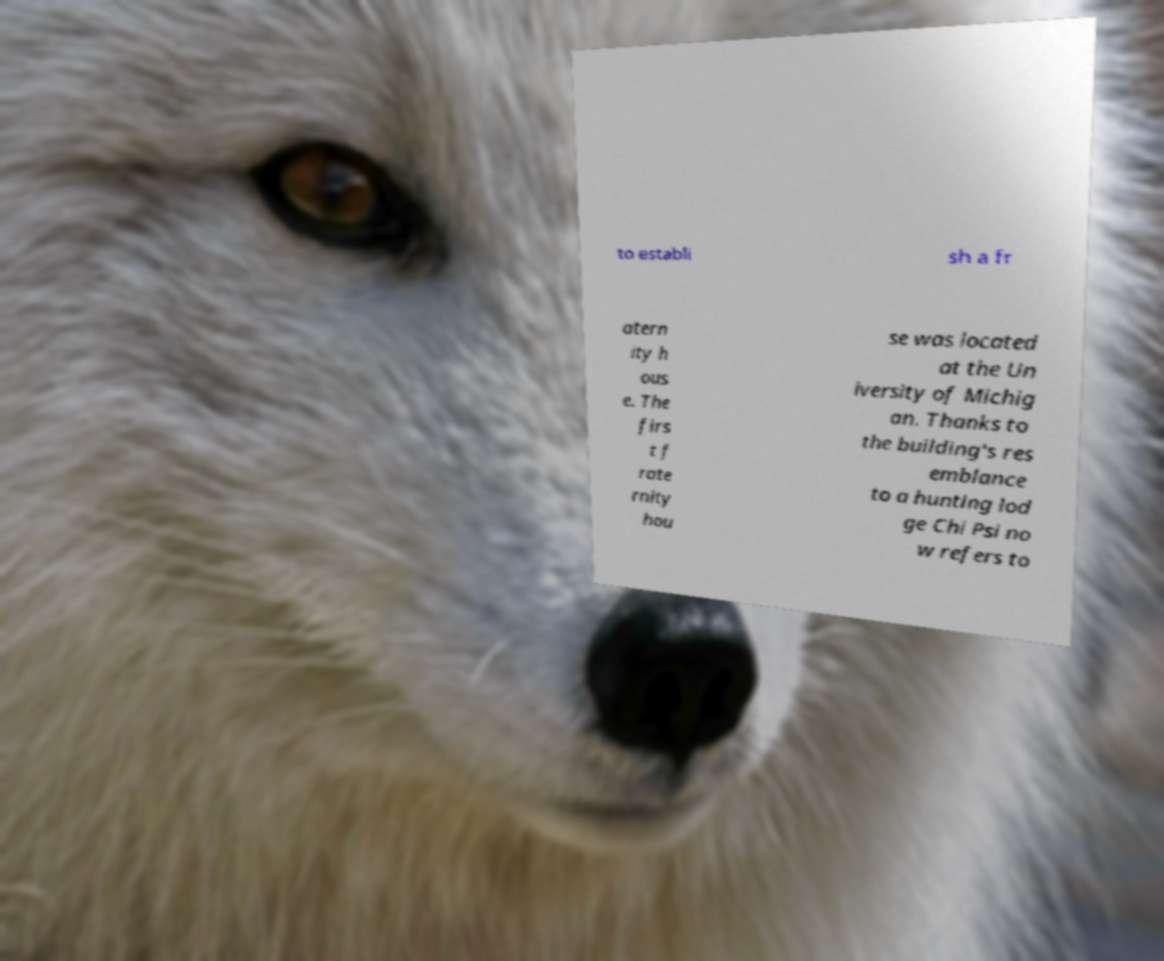Please identify and transcribe the text found in this image. to establi sh a fr atern ity h ous e. The firs t f rate rnity hou se was located at the Un iversity of Michig an. Thanks to the building's res emblance to a hunting lod ge Chi Psi no w refers to 